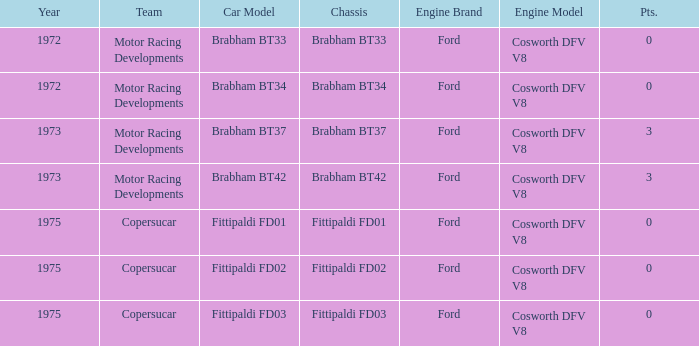Which engine from 1973 has a Brabham bt37 chassis? Ford Cosworth DFV V8. 